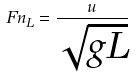Convert formula to latex. <formula><loc_0><loc_0><loc_500><loc_500>F n _ { L } = \frac { u } { \sqrt { g L } }</formula> 